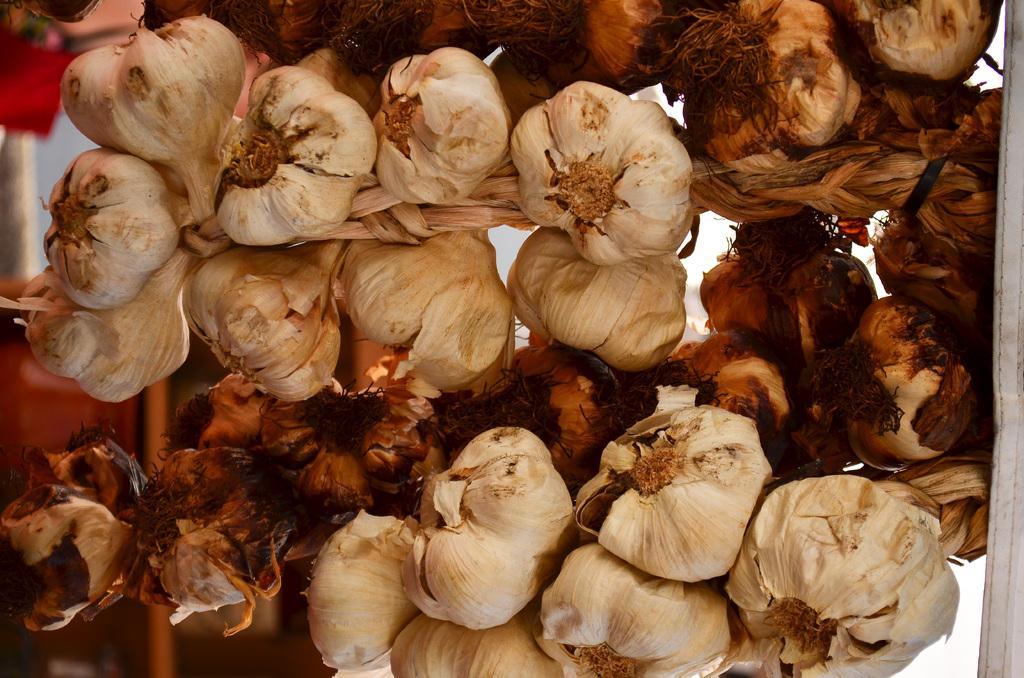How would you summarize this image in a sentence or two? In this image I can see garlic's. 